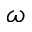<formula> <loc_0><loc_0><loc_500><loc_500>\omega</formula> 